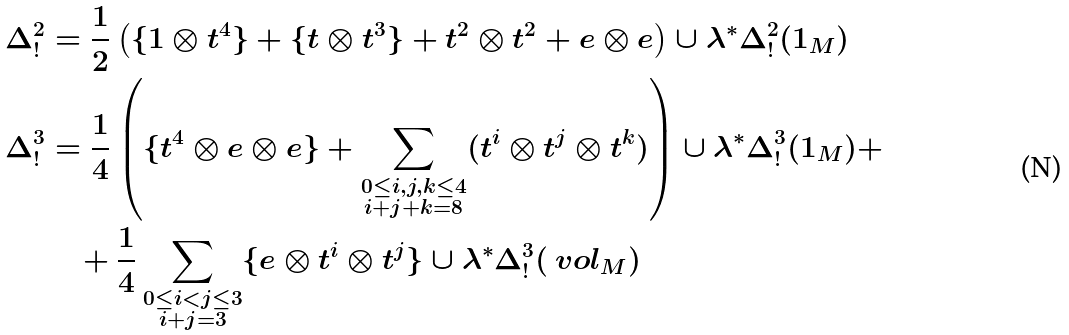<formula> <loc_0><loc_0><loc_500><loc_500>\Delta ^ { 2 } _ { ! } & = \frac { 1 } { 2 } \left ( \{ 1 \otimes t ^ { 4 } \} + \{ t \otimes t ^ { 3 } \} + t ^ { 2 } \otimes t ^ { 2 } + e \otimes e \right ) \cup \lambda ^ { * } \Delta _ { ! } ^ { 2 } ( 1 _ { M } ) \\ \Delta ^ { 3 } _ { ! } & = \frac { 1 } { 4 } \left ( \{ t ^ { 4 } \otimes e \otimes e \} + \sum _ { \substack { 0 \leq i , j , k \leq 4 \\ i + j + k = 8 } } ( t ^ { i } \otimes t ^ { j } \otimes t ^ { k } ) \right ) \cup \lambda ^ { * } \Delta ^ { 3 } _ { ! } ( 1 _ { M } ) + \\ & \quad + \frac { 1 } { 4 } \sum _ { \substack { 0 \leq i < j \leq 3 \\ i + j = 3 } } \{ e \otimes t ^ { i } \otimes t ^ { j } \} \cup \lambda ^ { * } \Delta _ { ! } ^ { 3 } ( \ v o l _ { M } )</formula> 